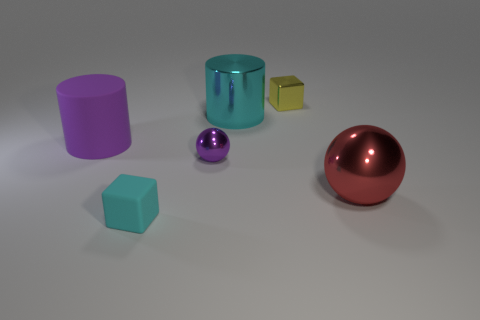Is the material of the purple sphere the same as the cube in front of the small shiny block?
Give a very brief answer. No. Are there fewer cyan cylinders that are behind the large matte cylinder than big yellow matte cubes?
Offer a terse response. No. How many other objects are there of the same shape as the big cyan thing?
Keep it short and to the point. 1. Is there any other thing that has the same color as the tiny rubber block?
Make the answer very short. Yes. There is a rubber cube; is it the same color as the block behind the red shiny sphere?
Provide a short and direct response. No. How many other objects are the same size as the yellow metallic object?
Offer a very short reply. 2. What size is the cube that is the same color as the shiny cylinder?
Your answer should be compact. Small. What number of cylinders are green objects or big purple objects?
Your response must be concise. 1. There is a thing that is behind the cyan shiny cylinder; is its shape the same as the small cyan matte thing?
Provide a succinct answer. Yes. Is the number of cyan cylinders that are in front of the cyan cube greater than the number of cylinders?
Offer a very short reply. No. 